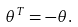<formula> <loc_0><loc_0><loc_500><loc_500>\theta ^ { T } = - \theta .</formula> 